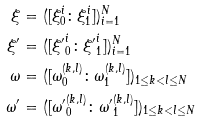<formula> <loc_0><loc_0><loc_500><loc_500>\xi & = ( [ \xi _ { 0 } ^ { i } \colon \xi _ { 1 } ^ { i } ] ) _ { i = 1 } ^ { N } \\ { \xi } ^ { \prime } & = ( [ { \xi ^ { \prime } } _ { 0 } ^ { i } \colon { \xi ^ { \prime } } _ { 1 } ^ { i } ] ) _ { i = 1 } ^ { N } \\ \omega & = ( [ \omega _ { 0 } ^ { ( k , l ) } \colon \omega _ { 1 } ^ { ( k , l ) } ] ) _ { 1 \leq k < l \leq N } \\ { \omega } ^ { \prime } & = ( [ { \omega ^ { \prime } } _ { 0 } ^ { ( k , l ) } \colon { \omega ^ { \prime } } _ { 1 } ^ { ( k , l ) } ] ) _ { 1 \leq k < l \leq N }</formula> 